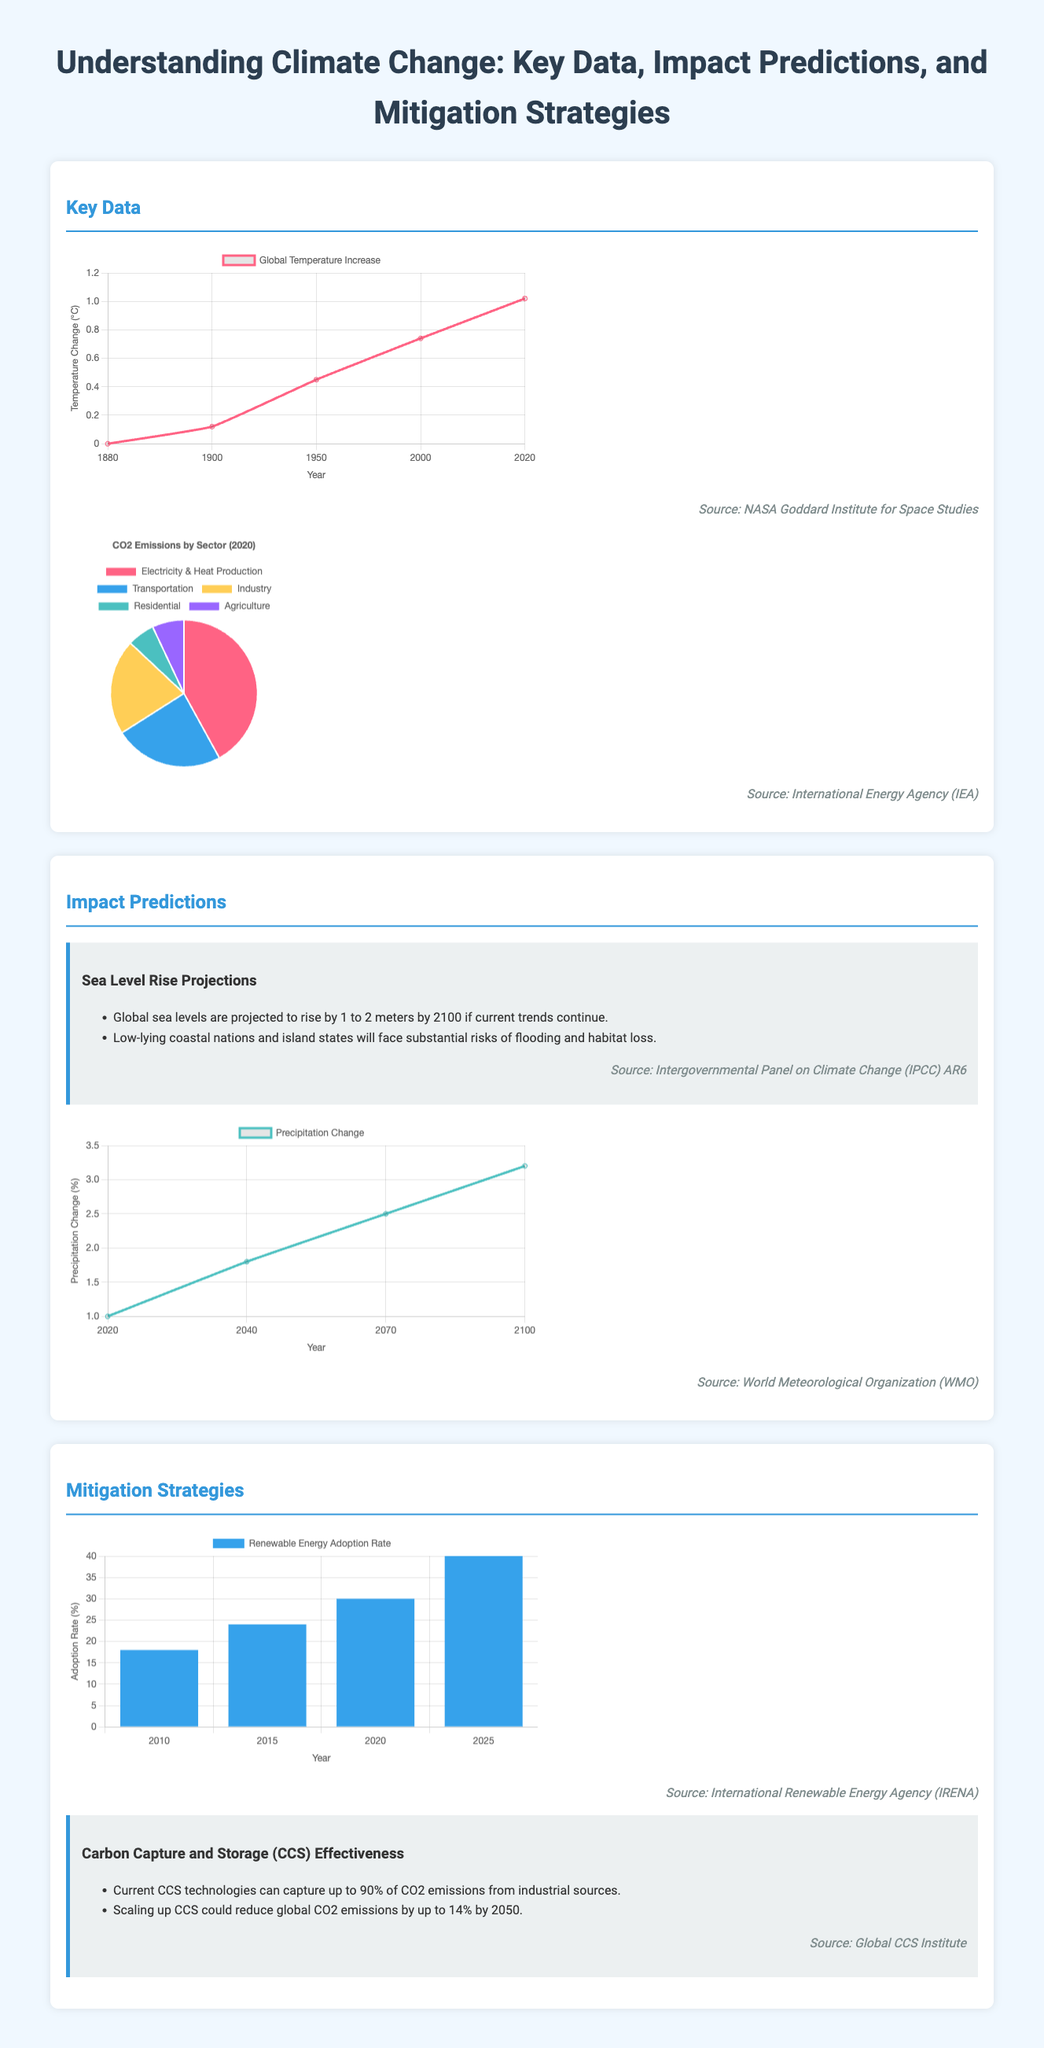What is the projected global sea level rise by 2100? The document states that global sea levels are projected to rise by 1 to 2 meters by 2100 if current trends continue.
Answer: 1 to 2 meters Which organization provided the source for temperature data? The infographic mentions that the temperature data is sourced from the NASA Goddard Institute for Space Studies.
Answer: NASA Goddard Institute for Space Studies What percentage of CO2 emissions can current Carbon Capture and Storage technologies capture? The document indicates that current CCS technologies can capture up to 90% of CO2 emissions from industrial sources.
Answer: 90% What year is the renewable energy adoption data for the highest percentage provided? The document shows that the renewable energy adoption rate is projected to reach 40% in the year 2025.
Answer: 2025 How many main sectors contribute to CO2 emissions shown in the emissions chart? The emissions chart lists five main sectors: Electricity & Heat Production, Transportation, Industry, Residential, and Agriculture.
Answer: Five What is the expected percentage change in precipitation by 2100? The infographic states that precipitation is projected to change by 3.2% by the year 2100.
Answer: 3.2% Who provided the source for the emissions chart? The source for the emissions chart is indicated as the International Energy Agency (IEA).
Answer: International Energy Agency (IEA) Which color represents the 'Transportation' sector in the emissions chart? The document specifies that the color representing the 'Transportation' sector is light blue.
Answer: Light blue 